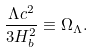Convert formula to latex. <formula><loc_0><loc_0><loc_500><loc_500>\frac { \Lambda c ^ { 2 } } { 3 H _ { b } ^ { 2 } } \equiv \Omega _ { \Lambda } .</formula> 